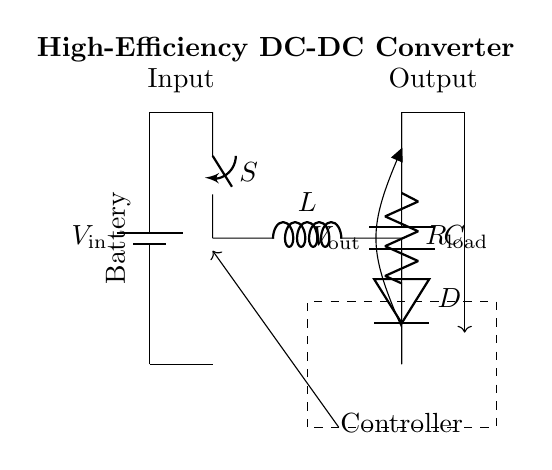What are the main components in this circuit? The circuit includes a battery, a switch, an inductor, a diode, a capacitor, a load resistor, and a controller. Each of these components plays a specific role in the conversion process.
Answer: Battery, switch, inductor, diode, capacitor, load resistor, controller What is the function of the inductor in this circuit? The inductor is responsible for storing energy in the magnetic field when the switch is closed and releasing it when the switch is open, aiding in voltage conversion.
Answer: Energy storage What is the purpose of the diode in the circuit? The diode allows current to flow in only one direction, preventing reverse current flow, which protects the circuit elements and ensures proper operation of the converter.
Answer: Prevent reverse current How does the controller influence the circuit operation? The controller regulates the switching of the switch based on the feedback from the output voltage, adjusting the duty cycle of the PWM signal to maintain the desired output voltage.
Answer: Regulates switching What type of converter is represented in this circuit? This circuit is a DC-DC converter which steps up or steps down the voltage from the battery to the output level necessary for the load.
Answer: DC-DC converter What does the feedback loop in the circuit indicate? The feedback loop communicates the output voltage back to the controller, enabling it to adjust the switch's operation to stabilize the output voltage.
Answer: Stabilizes output voltage How does this converter improve battery life in portable electronics? By operating efficiently with minimal energy loss and optimizing voltage to the required levels, the converter extends battery life, allowing for longer usage between charges.
Answer: Extends battery life 